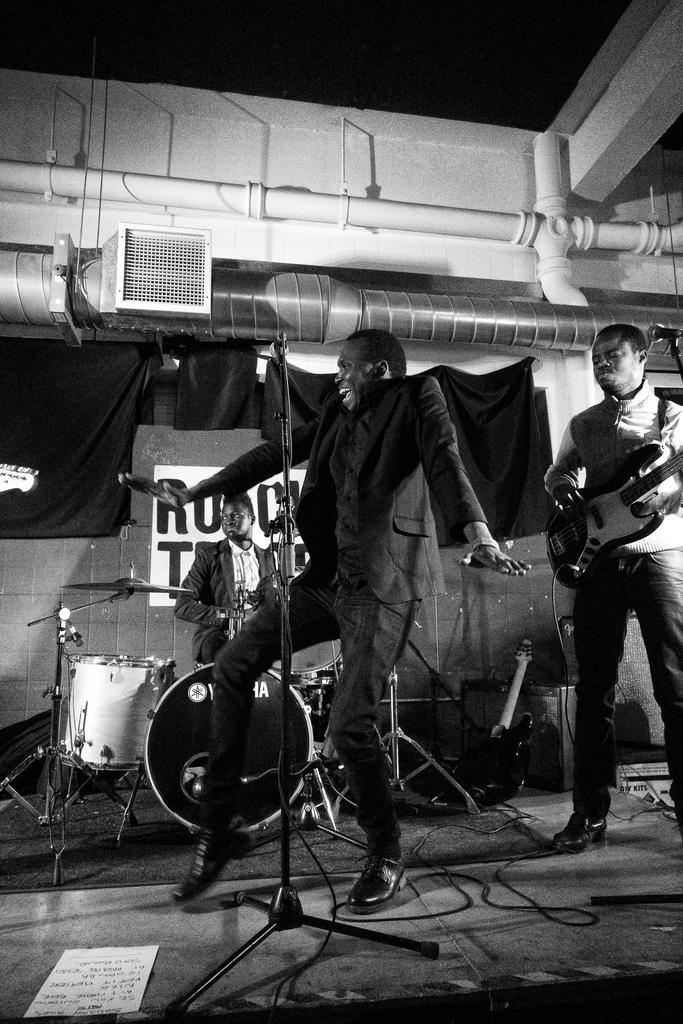Describe this image in one or two sentences. In this image on the right side there is one man who is standing and he is playing a guitar and on the left side there is one man who is dancing in front of him there is one mike, and on the floor there are some wires and one paper is there and on the background there is another person who is sitting and drumming. On the top there is ceiling and wall and some pipes are there. 